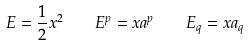<formula> <loc_0><loc_0><loc_500><loc_500>E = \frac { 1 } { 2 } x ^ { 2 } \quad E ^ { p } = x a ^ { p } \quad E _ { q } = x a _ { q }</formula> 